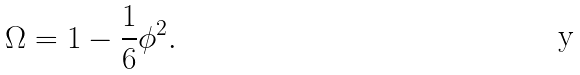<formula> <loc_0><loc_0><loc_500><loc_500>\Omega = 1 - \frac { 1 } { 6 } \phi ^ { 2 } .</formula> 